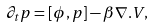Convert formula to latex. <formula><loc_0><loc_0><loc_500><loc_500>\partial _ { t } p = [ \phi , p ] - \beta \nabla . V ,</formula> 